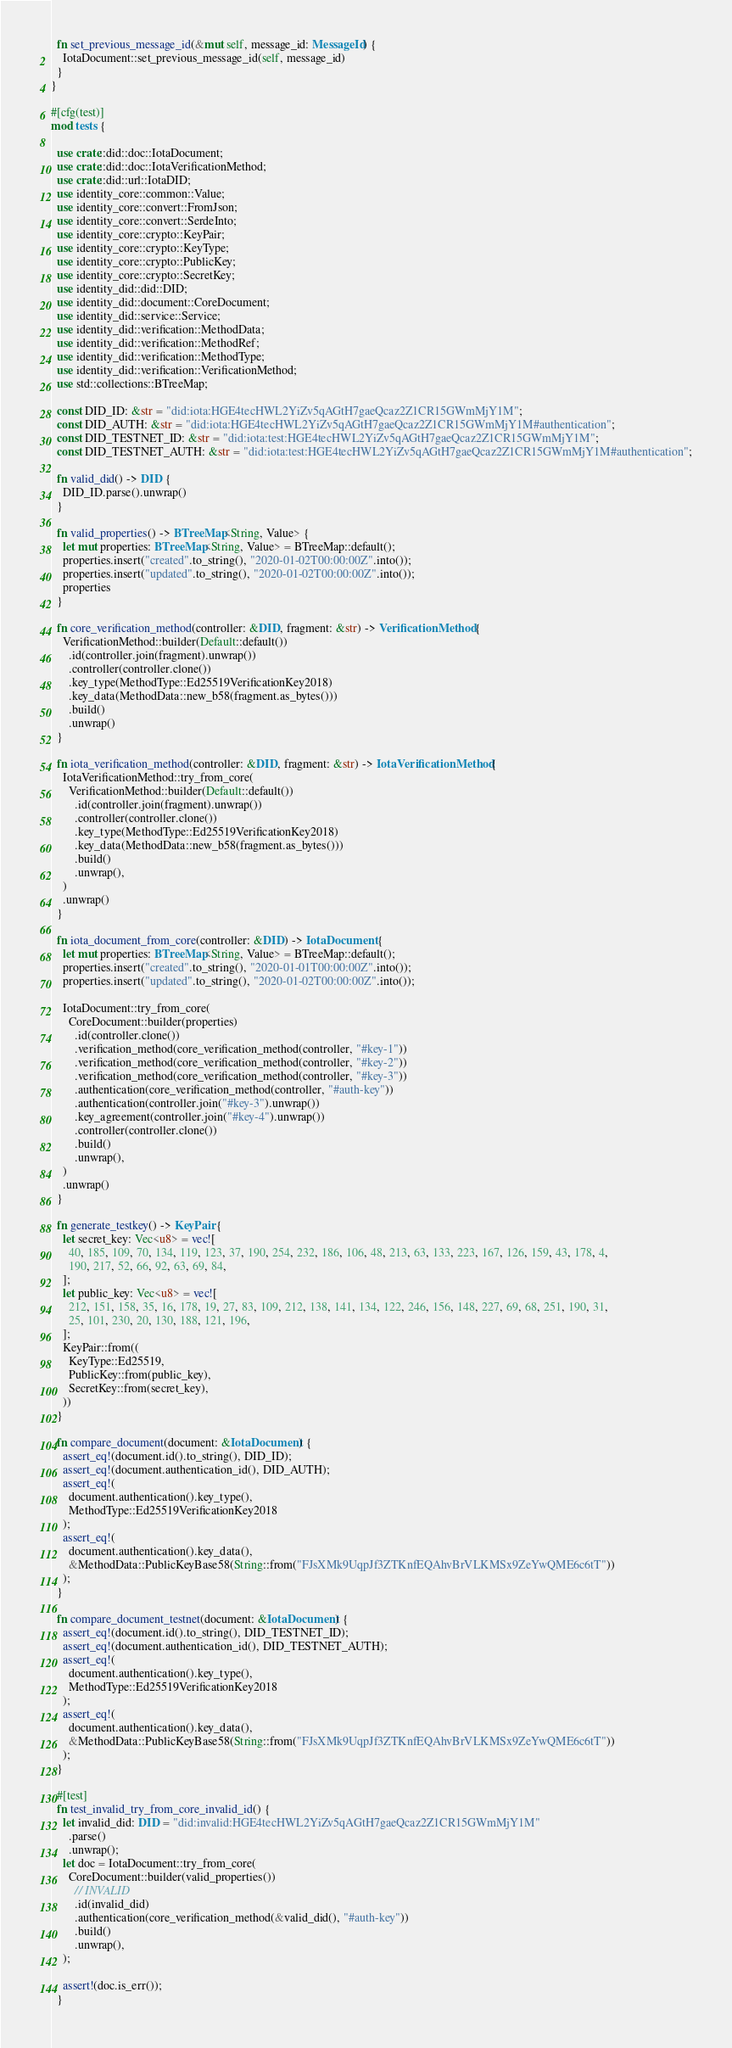Convert code to text. <code><loc_0><loc_0><loc_500><loc_500><_Rust_>  fn set_previous_message_id(&mut self, message_id: MessageId) {
    IotaDocument::set_previous_message_id(self, message_id)
  }
}

#[cfg(test)]
mod tests {

  use crate::did::doc::IotaDocument;
  use crate::did::doc::IotaVerificationMethod;
  use crate::did::url::IotaDID;
  use identity_core::common::Value;
  use identity_core::convert::FromJson;
  use identity_core::convert::SerdeInto;
  use identity_core::crypto::KeyPair;
  use identity_core::crypto::KeyType;
  use identity_core::crypto::PublicKey;
  use identity_core::crypto::SecretKey;
  use identity_did::did::DID;
  use identity_did::document::CoreDocument;
  use identity_did::service::Service;
  use identity_did::verification::MethodData;
  use identity_did::verification::MethodRef;
  use identity_did::verification::MethodType;
  use identity_did::verification::VerificationMethod;
  use std::collections::BTreeMap;

  const DID_ID: &str = "did:iota:HGE4tecHWL2YiZv5qAGtH7gaeQcaz2Z1CR15GWmMjY1M";
  const DID_AUTH: &str = "did:iota:HGE4tecHWL2YiZv5qAGtH7gaeQcaz2Z1CR15GWmMjY1M#authentication";
  const DID_TESTNET_ID: &str = "did:iota:test:HGE4tecHWL2YiZv5qAGtH7gaeQcaz2Z1CR15GWmMjY1M";
  const DID_TESTNET_AUTH: &str = "did:iota:test:HGE4tecHWL2YiZv5qAGtH7gaeQcaz2Z1CR15GWmMjY1M#authentication";

  fn valid_did() -> DID {
    DID_ID.parse().unwrap()
  }

  fn valid_properties() -> BTreeMap<String, Value> {
    let mut properties: BTreeMap<String, Value> = BTreeMap::default();
    properties.insert("created".to_string(), "2020-01-02T00:00:00Z".into());
    properties.insert("updated".to_string(), "2020-01-02T00:00:00Z".into());
    properties
  }

  fn core_verification_method(controller: &DID, fragment: &str) -> VerificationMethod {
    VerificationMethod::builder(Default::default())
      .id(controller.join(fragment).unwrap())
      .controller(controller.clone())
      .key_type(MethodType::Ed25519VerificationKey2018)
      .key_data(MethodData::new_b58(fragment.as_bytes()))
      .build()
      .unwrap()
  }

  fn iota_verification_method(controller: &DID, fragment: &str) -> IotaVerificationMethod {
    IotaVerificationMethod::try_from_core(
      VerificationMethod::builder(Default::default())
        .id(controller.join(fragment).unwrap())
        .controller(controller.clone())
        .key_type(MethodType::Ed25519VerificationKey2018)
        .key_data(MethodData::new_b58(fragment.as_bytes()))
        .build()
        .unwrap(),
    )
    .unwrap()
  }

  fn iota_document_from_core(controller: &DID) -> IotaDocument {
    let mut properties: BTreeMap<String, Value> = BTreeMap::default();
    properties.insert("created".to_string(), "2020-01-01T00:00:00Z".into());
    properties.insert("updated".to_string(), "2020-01-02T00:00:00Z".into());

    IotaDocument::try_from_core(
      CoreDocument::builder(properties)
        .id(controller.clone())
        .verification_method(core_verification_method(controller, "#key-1"))
        .verification_method(core_verification_method(controller, "#key-2"))
        .verification_method(core_verification_method(controller, "#key-3"))
        .authentication(core_verification_method(controller, "#auth-key"))
        .authentication(controller.join("#key-3").unwrap())
        .key_agreement(controller.join("#key-4").unwrap())
        .controller(controller.clone())
        .build()
        .unwrap(),
    )
    .unwrap()
  }

  fn generate_testkey() -> KeyPair {
    let secret_key: Vec<u8> = vec![
      40, 185, 109, 70, 134, 119, 123, 37, 190, 254, 232, 186, 106, 48, 213, 63, 133, 223, 167, 126, 159, 43, 178, 4,
      190, 217, 52, 66, 92, 63, 69, 84,
    ];
    let public_key: Vec<u8> = vec![
      212, 151, 158, 35, 16, 178, 19, 27, 83, 109, 212, 138, 141, 134, 122, 246, 156, 148, 227, 69, 68, 251, 190, 31,
      25, 101, 230, 20, 130, 188, 121, 196,
    ];
    KeyPair::from((
      KeyType::Ed25519,
      PublicKey::from(public_key),
      SecretKey::from(secret_key),
    ))
  }

  fn compare_document(document: &IotaDocument) {
    assert_eq!(document.id().to_string(), DID_ID);
    assert_eq!(document.authentication_id(), DID_AUTH);
    assert_eq!(
      document.authentication().key_type(),
      MethodType::Ed25519VerificationKey2018
    );
    assert_eq!(
      document.authentication().key_data(),
      &MethodData::PublicKeyBase58(String::from("FJsXMk9UqpJf3ZTKnfEQAhvBrVLKMSx9ZeYwQME6c6tT"))
    );
  }

  fn compare_document_testnet(document: &IotaDocument) {
    assert_eq!(document.id().to_string(), DID_TESTNET_ID);
    assert_eq!(document.authentication_id(), DID_TESTNET_AUTH);
    assert_eq!(
      document.authentication().key_type(),
      MethodType::Ed25519VerificationKey2018
    );
    assert_eq!(
      document.authentication().key_data(),
      &MethodData::PublicKeyBase58(String::from("FJsXMk9UqpJf3ZTKnfEQAhvBrVLKMSx9ZeYwQME6c6tT"))
    );
  }

  #[test]
  fn test_invalid_try_from_core_invalid_id() {
    let invalid_did: DID = "did:invalid:HGE4tecHWL2YiZv5qAGtH7gaeQcaz2Z1CR15GWmMjY1M"
      .parse()
      .unwrap();
    let doc = IotaDocument::try_from_core(
      CoreDocument::builder(valid_properties())
        // INVALID
        .id(invalid_did)
        .authentication(core_verification_method(&valid_did(), "#auth-key"))
        .build()
        .unwrap(),
    );

    assert!(doc.is_err());
  }
</code> 